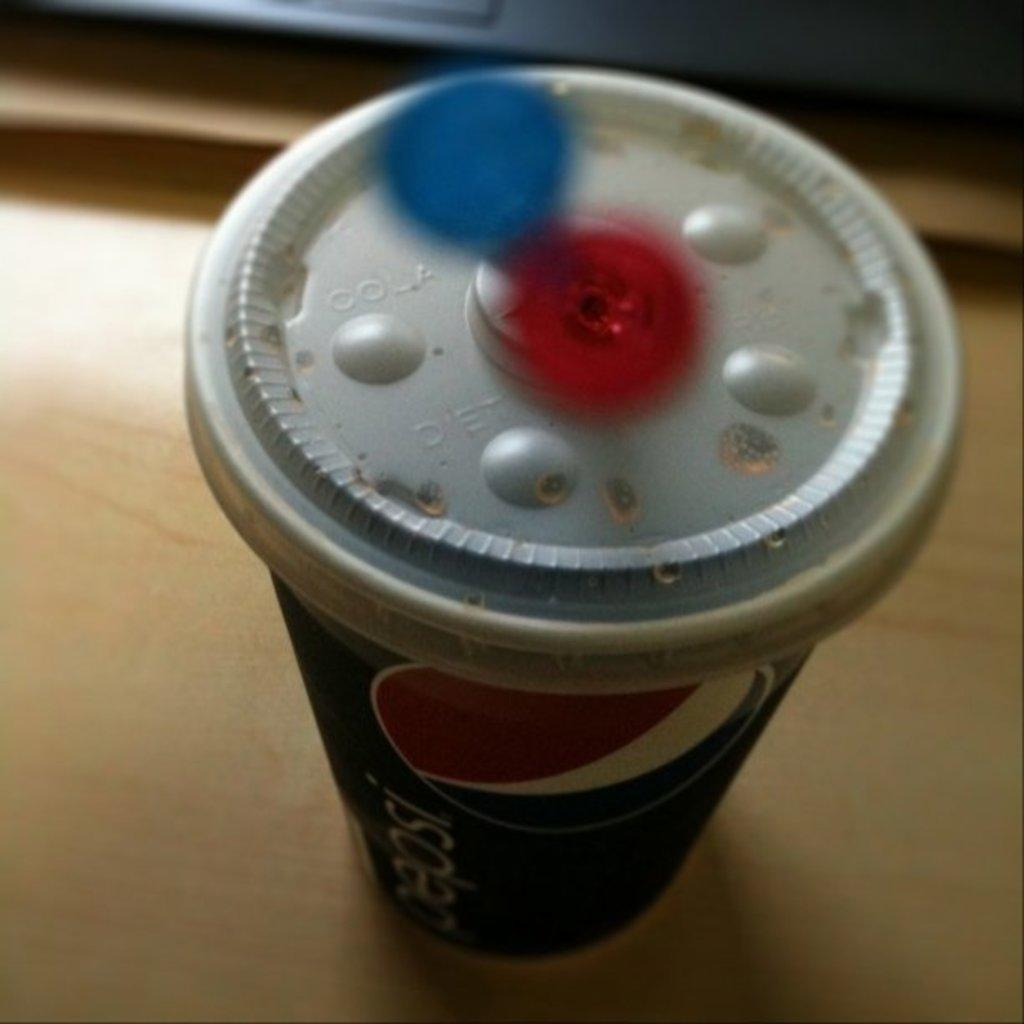<image>
Present a compact description of the photo's key features. Pepsi is the brand name displayed on the side of this cup. 